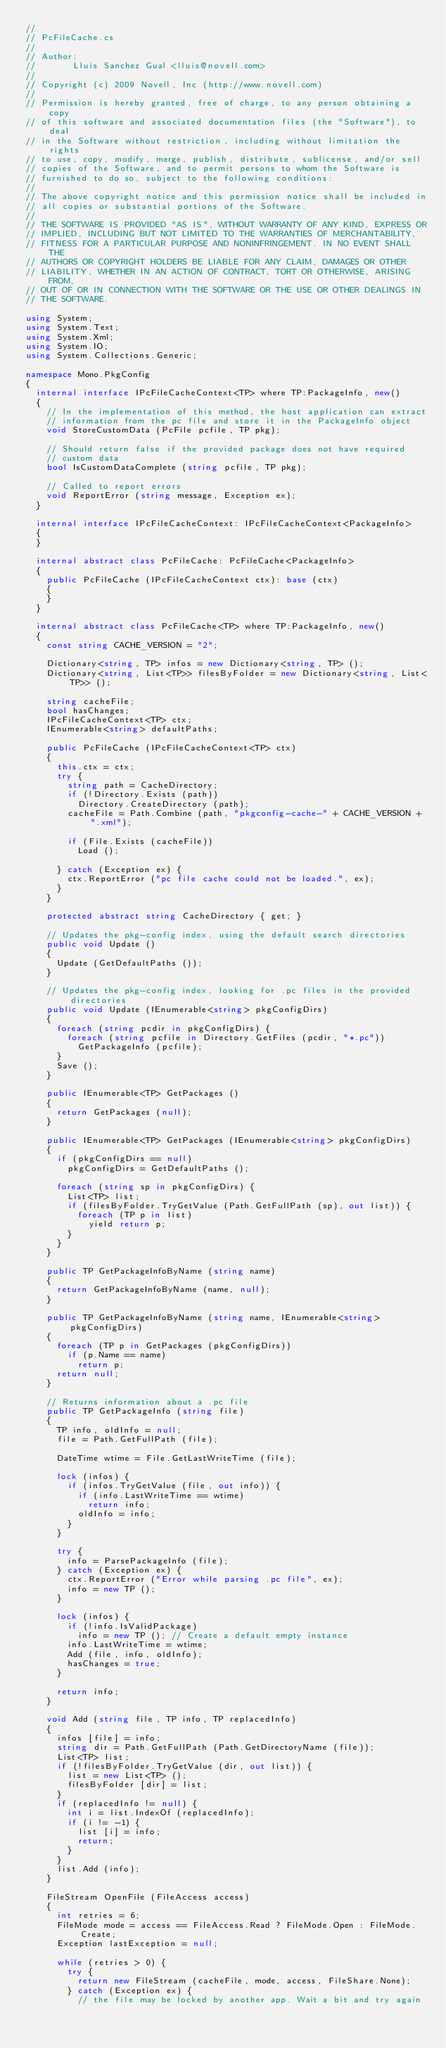<code> <loc_0><loc_0><loc_500><loc_500><_C#_>// 
// PcFileCache.cs
//  
// Author:
//       Lluis Sanchez Gual <lluis@novell.com>
// 
// Copyright (c) 2009 Novell, Inc (http://www.novell.com)
// 
// Permission is hereby granted, free of charge, to any person obtaining a copy
// of this software and associated documentation files (the "Software"), to deal
// in the Software without restriction, including without limitation the rights
// to use, copy, modify, merge, publish, distribute, sublicense, and/or sell
// copies of the Software, and to permit persons to whom the Software is
// furnished to do so, subject to the following conditions:
// 
// The above copyright notice and this permission notice shall be included in
// all copies or substantial portions of the Software.
// 
// THE SOFTWARE IS PROVIDED "AS IS", WITHOUT WARRANTY OF ANY KIND, EXPRESS OR
// IMPLIED, INCLUDING BUT NOT LIMITED TO THE WARRANTIES OF MERCHANTABILITY,
// FITNESS FOR A PARTICULAR PURPOSE AND NONINFRINGEMENT. IN NO EVENT SHALL THE
// AUTHORS OR COPYRIGHT HOLDERS BE LIABLE FOR ANY CLAIM, DAMAGES OR OTHER
// LIABILITY, WHETHER IN AN ACTION OF CONTRACT, TORT OR OTHERWISE, ARISING FROM,
// OUT OF OR IN CONNECTION WITH THE SOFTWARE OR THE USE OR OTHER DEALINGS IN
// THE SOFTWARE.

using System;
using System.Text;
using System.Xml;
using System.IO;
using System.Collections.Generic;

namespace Mono.PkgConfig
{
	internal interface IPcFileCacheContext<TP> where TP:PackageInfo, new()
	{
		// In the implementation of this method, the host application can extract
		// information from the pc file and store it in the PackageInfo object
		void StoreCustomData (PcFile pcfile, TP pkg);
		
		// Should return false if the provided package does not have required
		// custom data
		bool IsCustomDataComplete (string pcfile, TP pkg);
		
		// Called to report errors
		void ReportError (string message, Exception ex);
	}
	
	internal interface IPcFileCacheContext: IPcFileCacheContext<PackageInfo>
	{
	}
	
	internal abstract class PcFileCache: PcFileCache<PackageInfo>
	{
		public PcFileCache (IPcFileCacheContext ctx): base (ctx)
		{
		}
	}
	
	internal abstract class PcFileCache<TP> where TP:PackageInfo, new()
	{
		const string CACHE_VERSION = "2";
		
		Dictionary<string, TP> infos = new Dictionary<string, TP> ();
		Dictionary<string, List<TP>> filesByFolder = new Dictionary<string, List<TP>> ();
		
		string cacheFile;
		bool hasChanges;
		IPcFileCacheContext<TP> ctx;
		IEnumerable<string> defaultPaths;
		
		public PcFileCache (IPcFileCacheContext<TP> ctx)
		{
			this.ctx = ctx;
			try {
				string path = CacheDirectory;
				if (!Directory.Exists (path))
					Directory.CreateDirectory (path);
				cacheFile = Path.Combine (path, "pkgconfig-cache-" + CACHE_VERSION + ".xml");
				
				if (File.Exists (cacheFile))
					Load ();
				
			} catch (Exception ex) {
				ctx.ReportError ("pc file cache could not be loaded.", ex);
			}
		}
		
		protected abstract string CacheDirectory { get; }
		
		// Updates the pkg-config index, using the default search directories
		public void Update ()
		{
			Update (GetDefaultPaths ());
		}

		// Updates the pkg-config index, looking for .pc files in the provided directories
		public void Update (IEnumerable<string> pkgConfigDirs)
		{
			foreach (string pcdir in pkgConfigDirs) {
				foreach (string pcfile in Directory.GetFiles (pcdir, "*.pc"))
					GetPackageInfo (pcfile);
			}
			Save ();
		}
		
		public IEnumerable<TP> GetPackages ()
		{
			return GetPackages (null);
		}
		
		public IEnumerable<TP> GetPackages (IEnumerable<string> pkgConfigDirs)
		{
			if (pkgConfigDirs == null)
				pkgConfigDirs = GetDefaultPaths ();

			foreach (string sp in pkgConfigDirs) {
				List<TP> list;
				if (filesByFolder.TryGetValue (Path.GetFullPath (sp), out list)) {
					foreach (TP p in list)
						yield return p;
				}
			}
		}
		
		public TP GetPackageInfoByName (string name)
		{
			return GetPackageInfoByName (name, null);
		}
		
		public TP GetPackageInfoByName (string name, IEnumerable<string> pkgConfigDirs)
		{
			foreach (TP p in GetPackages (pkgConfigDirs))
				if (p.Name == name)
					return p;
			return null;
		}
		
		// Returns information about a .pc file
		public TP GetPackageInfo (string file)
		{
			TP info, oldInfo = null;
			file = Path.GetFullPath (file);
			
			DateTime wtime = File.GetLastWriteTime (file);
			
			lock (infos) {
				if (infos.TryGetValue (file, out info)) {
					if (info.LastWriteTime == wtime)
						return info;
					oldInfo = info;
				}
			}

			try {
				info = ParsePackageInfo (file);
			} catch (Exception ex) {
				ctx.ReportError ("Error while parsing .pc file", ex);
				info = new TP ();
			}
			
			lock (infos) {
				if (!info.IsValidPackage)
					info = new TP (); // Create a default empty instance
				info.LastWriteTime = wtime;
				Add (file, info, oldInfo);
				hasChanges = true;
			}
			
			return info;
		}
		
		void Add (string file, TP info, TP replacedInfo)
		{
			infos [file] = info;
			string dir = Path.GetFullPath (Path.GetDirectoryName (file));
			List<TP> list;
			if (!filesByFolder.TryGetValue (dir, out list)) {
				list = new List<TP> ();
				filesByFolder [dir] = list;
			}
			if (replacedInfo != null) {
				int i = list.IndexOf (replacedInfo);
				if (i != -1) {
					list [i] = info;
					return;
				}
			}
			list.Add (info);
		}
		
		FileStream OpenFile (FileAccess access)
		{
			int retries = 6;
			FileMode mode = access == FileAccess.Read ? FileMode.Open : FileMode.Create;
			Exception lastException = null;
			
			while (retries > 0) {
				try {
					return new FileStream (cacheFile, mode, access, FileShare.None);
				} catch (Exception ex) {
					// the file may be locked by another app. Wait a bit and try again</code> 